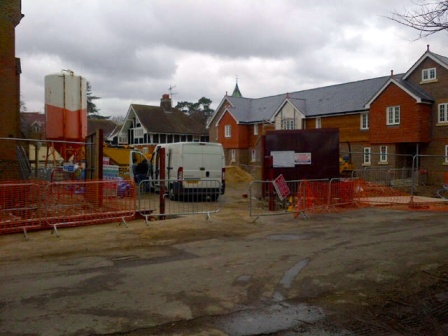What might be happening behind the large construction vehicle? Behind the large construction vehicle, it's likely that various activities essential to the house-building process are taking place. Workers might be laying foundations, assembling frameworks, or installing utility systems such as electrical wiring and plumbing. Given the visible materials and equipment, there could be tasks such as pouring concrete, arranging bricks, or finishing exterior walls. The area might also serve as a staging ground for tools and materials, ensuring everything needed for the construction is within easy reach. Do you think this site will have a playground once the construction is finished? It's quite possible that the residential development will include a playground or other communal amenities. Many new residential areas aim to create family-friendly environments, and providing recreational spaces encourages a sense of community. The presence of multiple homes under construction points to the development of a neighborhood, and integrating a playground would align well with creating an attractive living area for potential residents, particularly families. 